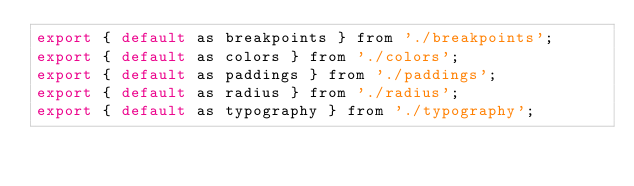Convert code to text. <code><loc_0><loc_0><loc_500><loc_500><_JavaScript_>export { default as breakpoints } from './breakpoints';
export { default as colors } from './colors';
export { default as paddings } from './paddings';
export { default as radius } from './radius';
export { default as typography } from './typography';
</code> 